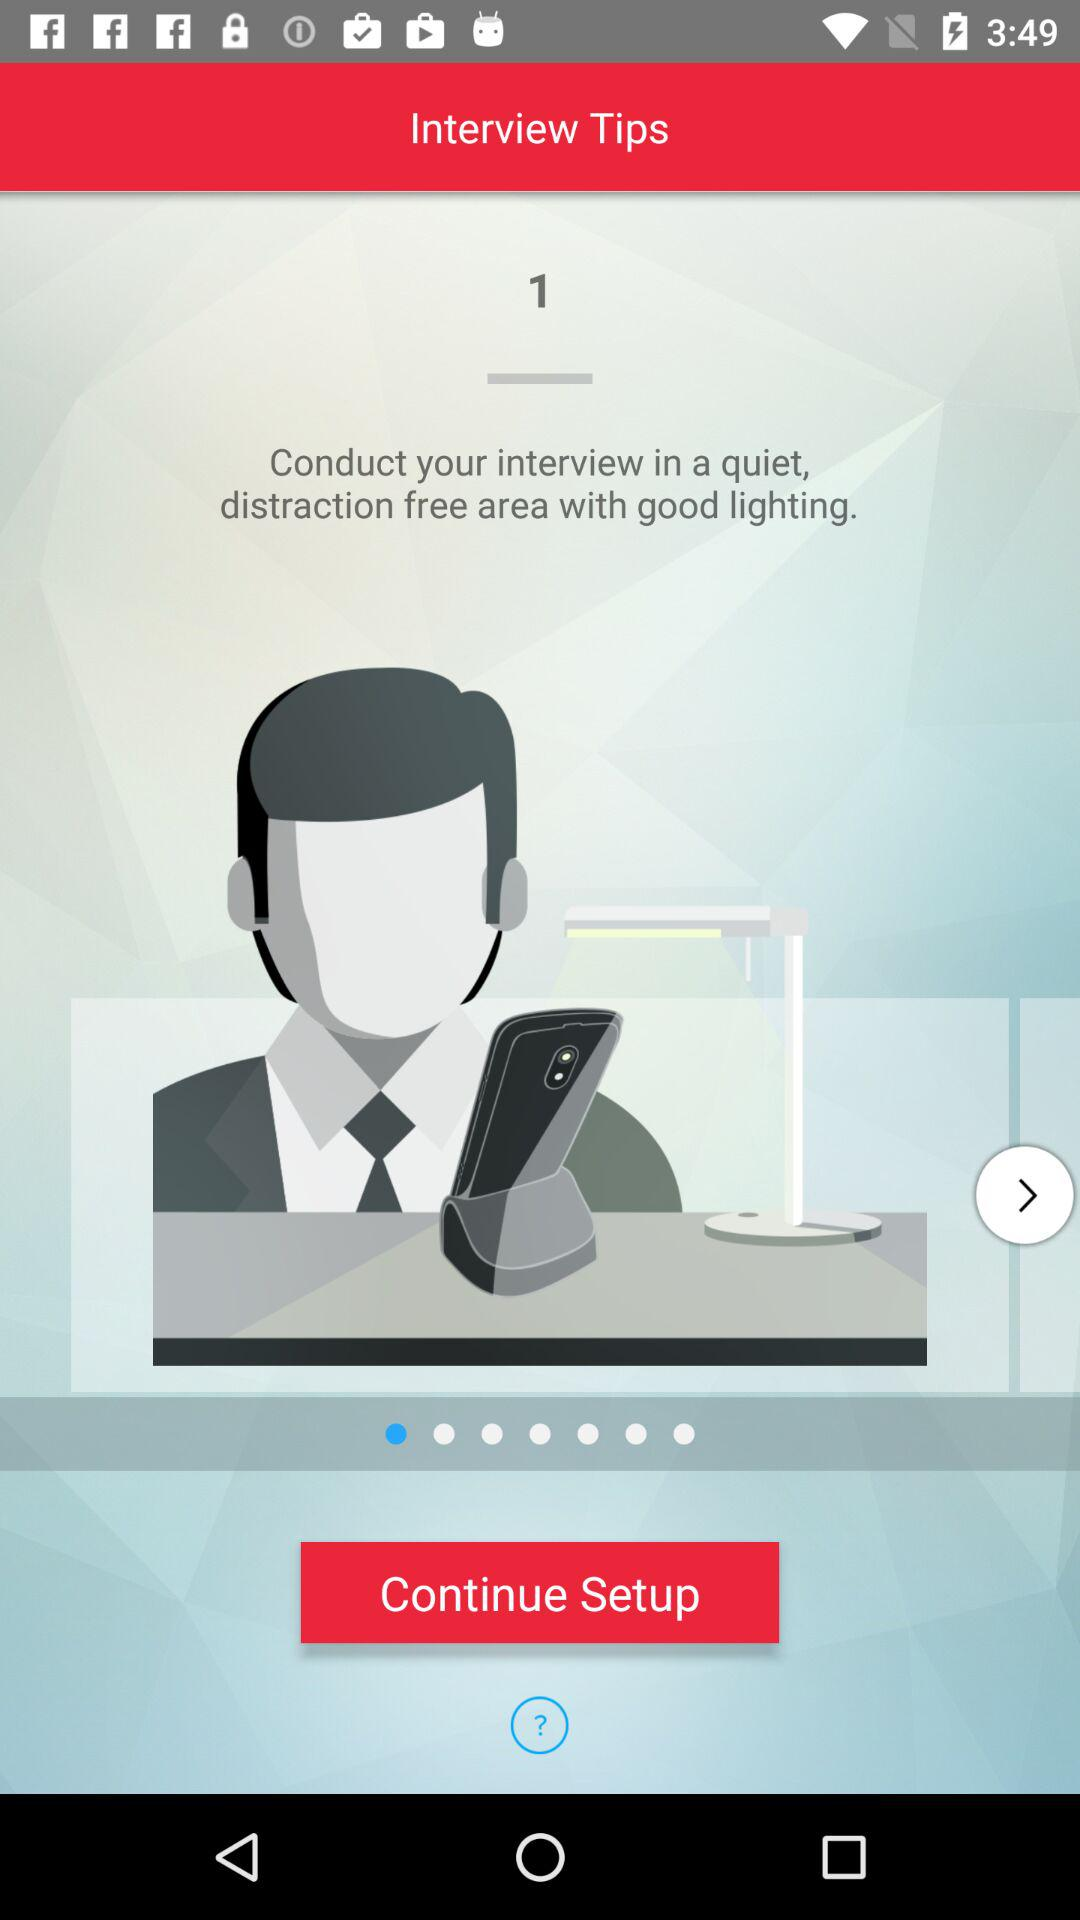Where should the interview be conducted? The interview should be conducted in a quiet, distraction-free area with good lighting. 